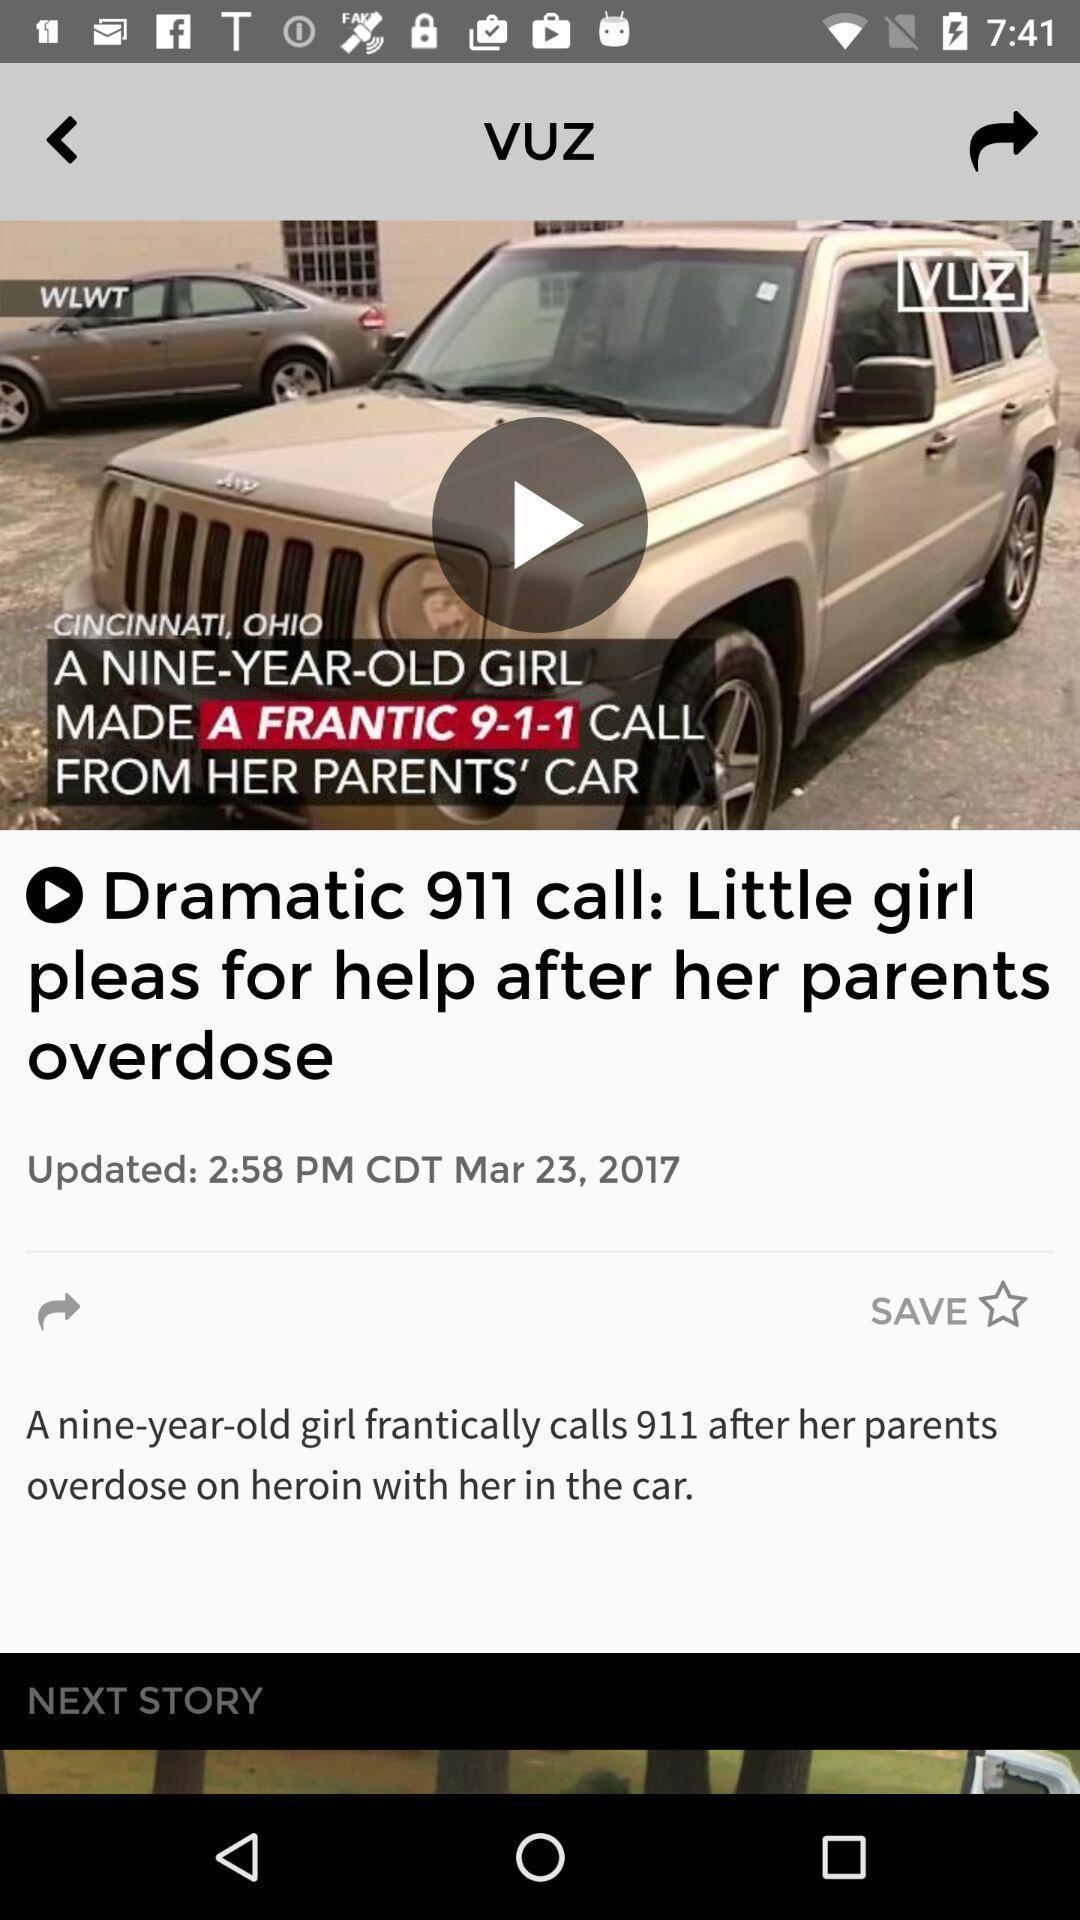Provide a description of this screenshot. Video of the news in the app. 